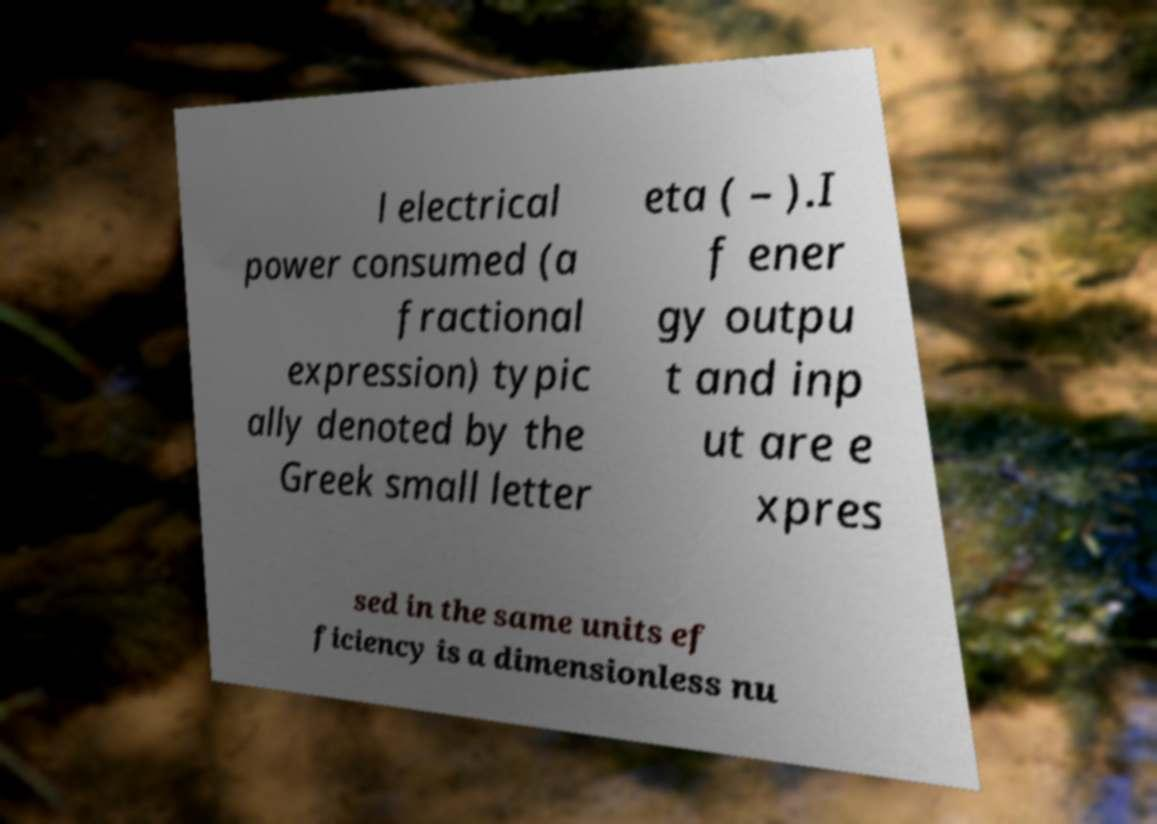I need the written content from this picture converted into text. Can you do that? l electrical power consumed (a fractional expression) typic ally denoted by the Greek small letter eta ( – ).I f ener gy outpu t and inp ut are e xpres sed in the same units ef ficiency is a dimensionless nu 